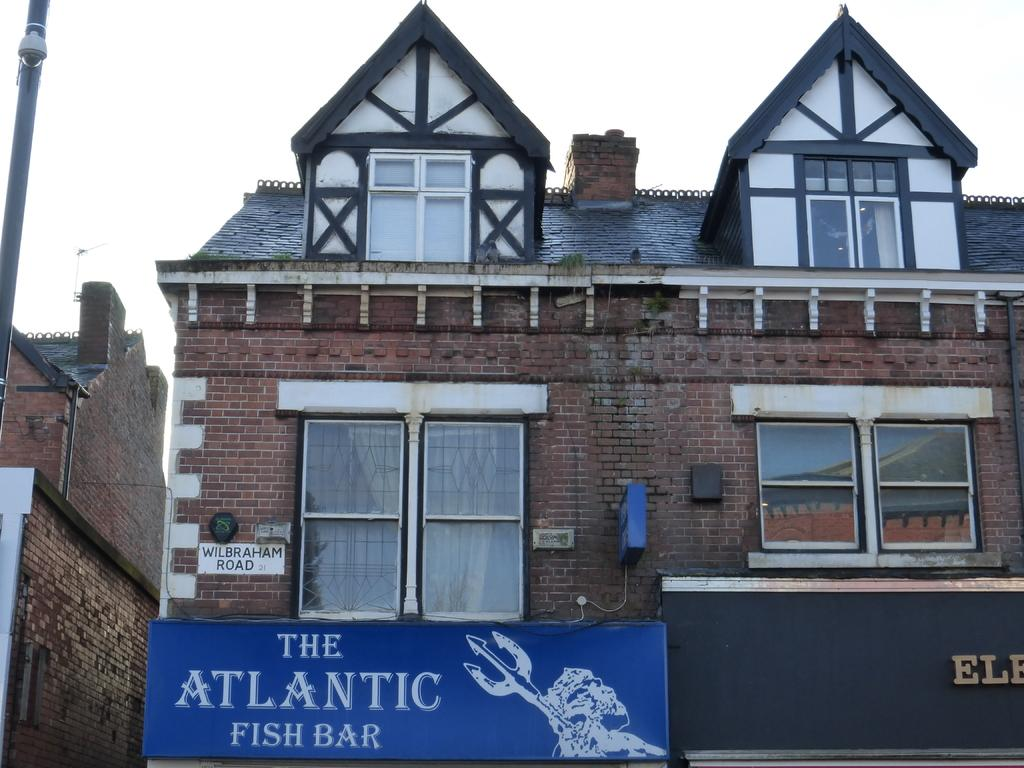What is the main structure in the center of the image? There is a building in the center of the image. What can be seen on the left side of the image? There is a pole on the left side of the image. How many elbows are visible in the image? There are no elbows visible in the image. What type of servant can be seen working in the building in the image? There is no servant present in the image, and the image does not provide any information about the building's occupants or workers. 